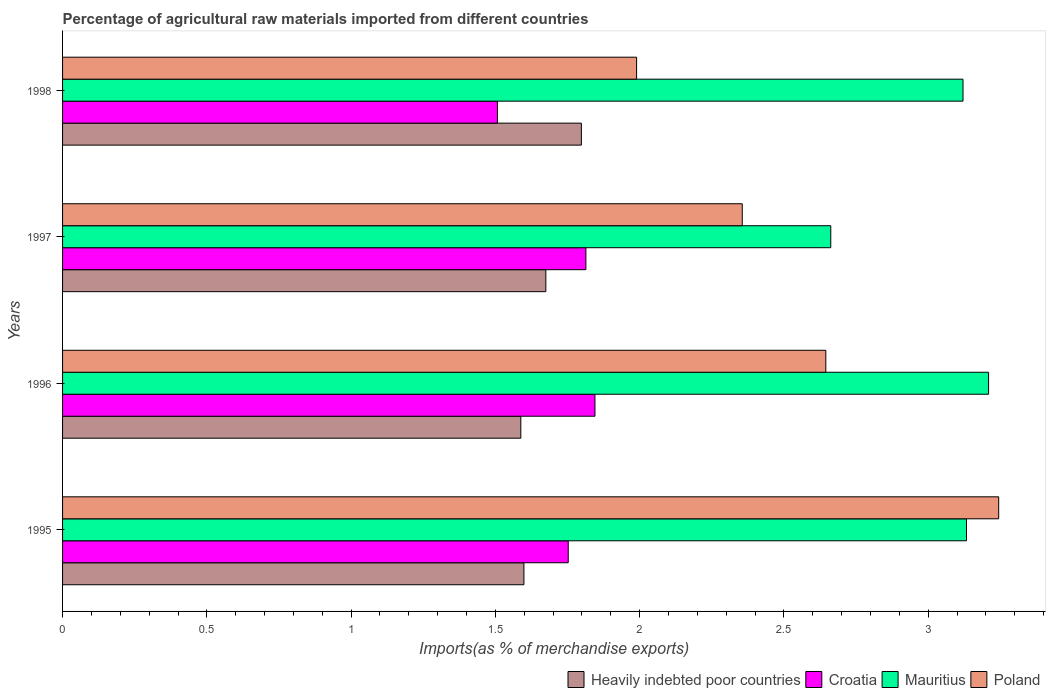How many different coloured bars are there?
Give a very brief answer. 4. Are the number of bars per tick equal to the number of legend labels?
Keep it short and to the point. Yes. Are the number of bars on each tick of the Y-axis equal?
Your answer should be compact. Yes. How many bars are there on the 1st tick from the bottom?
Offer a very short reply. 4. What is the percentage of imports to different countries in Mauritius in 1996?
Your answer should be very brief. 3.21. Across all years, what is the maximum percentage of imports to different countries in Mauritius?
Keep it short and to the point. 3.21. Across all years, what is the minimum percentage of imports to different countries in Mauritius?
Ensure brevity in your answer.  2.66. In which year was the percentage of imports to different countries in Poland minimum?
Your answer should be very brief. 1998. What is the total percentage of imports to different countries in Croatia in the graph?
Offer a terse response. 6.92. What is the difference between the percentage of imports to different countries in Poland in 1996 and that in 1997?
Ensure brevity in your answer.  0.29. What is the difference between the percentage of imports to different countries in Poland in 1998 and the percentage of imports to different countries in Mauritius in 1997?
Give a very brief answer. -0.67. What is the average percentage of imports to different countries in Mauritius per year?
Provide a succinct answer. 3.03. In the year 1997, what is the difference between the percentage of imports to different countries in Croatia and percentage of imports to different countries in Heavily indebted poor countries?
Keep it short and to the point. 0.14. In how many years, is the percentage of imports to different countries in Mauritius greater than 0.30000000000000004 %?
Provide a short and direct response. 4. What is the ratio of the percentage of imports to different countries in Poland in 1995 to that in 1997?
Offer a very short reply. 1.38. Is the percentage of imports to different countries in Croatia in 1997 less than that in 1998?
Offer a very short reply. No. What is the difference between the highest and the second highest percentage of imports to different countries in Heavily indebted poor countries?
Provide a short and direct response. 0.12. What is the difference between the highest and the lowest percentage of imports to different countries in Croatia?
Ensure brevity in your answer.  0.34. What does the 4th bar from the top in 1997 represents?
Your response must be concise. Heavily indebted poor countries. What does the 3rd bar from the bottom in 1998 represents?
Provide a succinct answer. Mauritius. How many bars are there?
Your answer should be compact. 16. Are all the bars in the graph horizontal?
Keep it short and to the point. Yes. How many years are there in the graph?
Your answer should be very brief. 4. Does the graph contain any zero values?
Make the answer very short. No. How are the legend labels stacked?
Your answer should be very brief. Horizontal. What is the title of the graph?
Make the answer very short. Percentage of agricultural raw materials imported from different countries. What is the label or title of the X-axis?
Offer a terse response. Imports(as % of merchandise exports). What is the label or title of the Y-axis?
Offer a terse response. Years. What is the Imports(as % of merchandise exports) of Heavily indebted poor countries in 1995?
Provide a short and direct response. 1.6. What is the Imports(as % of merchandise exports) in Croatia in 1995?
Offer a terse response. 1.75. What is the Imports(as % of merchandise exports) in Mauritius in 1995?
Ensure brevity in your answer.  3.13. What is the Imports(as % of merchandise exports) in Poland in 1995?
Your answer should be very brief. 3.24. What is the Imports(as % of merchandise exports) of Heavily indebted poor countries in 1996?
Make the answer very short. 1.59. What is the Imports(as % of merchandise exports) of Croatia in 1996?
Your response must be concise. 1.84. What is the Imports(as % of merchandise exports) in Mauritius in 1996?
Keep it short and to the point. 3.21. What is the Imports(as % of merchandise exports) of Poland in 1996?
Ensure brevity in your answer.  2.64. What is the Imports(as % of merchandise exports) of Heavily indebted poor countries in 1997?
Provide a succinct answer. 1.67. What is the Imports(as % of merchandise exports) in Croatia in 1997?
Your answer should be very brief. 1.81. What is the Imports(as % of merchandise exports) of Mauritius in 1997?
Give a very brief answer. 2.66. What is the Imports(as % of merchandise exports) of Poland in 1997?
Give a very brief answer. 2.36. What is the Imports(as % of merchandise exports) in Heavily indebted poor countries in 1998?
Your answer should be compact. 1.8. What is the Imports(as % of merchandise exports) in Croatia in 1998?
Provide a succinct answer. 1.51. What is the Imports(as % of merchandise exports) in Mauritius in 1998?
Offer a terse response. 3.12. What is the Imports(as % of merchandise exports) in Poland in 1998?
Offer a terse response. 1.99. Across all years, what is the maximum Imports(as % of merchandise exports) in Heavily indebted poor countries?
Keep it short and to the point. 1.8. Across all years, what is the maximum Imports(as % of merchandise exports) of Croatia?
Ensure brevity in your answer.  1.84. Across all years, what is the maximum Imports(as % of merchandise exports) of Mauritius?
Your response must be concise. 3.21. Across all years, what is the maximum Imports(as % of merchandise exports) in Poland?
Your answer should be compact. 3.24. Across all years, what is the minimum Imports(as % of merchandise exports) in Heavily indebted poor countries?
Keep it short and to the point. 1.59. Across all years, what is the minimum Imports(as % of merchandise exports) of Croatia?
Your answer should be very brief. 1.51. Across all years, what is the minimum Imports(as % of merchandise exports) in Mauritius?
Offer a terse response. 2.66. Across all years, what is the minimum Imports(as % of merchandise exports) in Poland?
Provide a short and direct response. 1.99. What is the total Imports(as % of merchandise exports) in Heavily indebted poor countries in the graph?
Your answer should be compact. 6.66. What is the total Imports(as % of merchandise exports) of Croatia in the graph?
Offer a terse response. 6.92. What is the total Imports(as % of merchandise exports) in Mauritius in the graph?
Your answer should be compact. 12.12. What is the total Imports(as % of merchandise exports) in Poland in the graph?
Provide a succinct answer. 10.23. What is the difference between the Imports(as % of merchandise exports) in Heavily indebted poor countries in 1995 and that in 1996?
Provide a short and direct response. 0.01. What is the difference between the Imports(as % of merchandise exports) in Croatia in 1995 and that in 1996?
Offer a terse response. -0.09. What is the difference between the Imports(as % of merchandise exports) of Mauritius in 1995 and that in 1996?
Provide a short and direct response. -0.08. What is the difference between the Imports(as % of merchandise exports) of Poland in 1995 and that in 1996?
Your response must be concise. 0.6. What is the difference between the Imports(as % of merchandise exports) in Heavily indebted poor countries in 1995 and that in 1997?
Your response must be concise. -0.08. What is the difference between the Imports(as % of merchandise exports) of Croatia in 1995 and that in 1997?
Your response must be concise. -0.06. What is the difference between the Imports(as % of merchandise exports) in Mauritius in 1995 and that in 1997?
Your answer should be compact. 0.47. What is the difference between the Imports(as % of merchandise exports) of Poland in 1995 and that in 1997?
Your response must be concise. 0.89. What is the difference between the Imports(as % of merchandise exports) of Heavily indebted poor countries in 1995 and that in 1998?
Your answer should be very brief. -0.2. What is the difference between the Imports(as % of merchandise exports) of Croatia in 1995 and that in 1998?
Your answer should be compact. 0.25. What is the difference between the Imports(as % of merchandise exports) in Mauritius in 1995 and that in 1998?
Give a very brief answer. 0.01. What is the difference between the Imports(as % of merchandise exports) in Poland in 1995 and that in 1998?
Provide a short and direct response. 1.25. What is the difference between the Imports(as % of merchandise exports) of Heavily indebted poor countries in 1996 and that in 1997?
Keep it short and to the point. -0.09. What is the difference between the Imports(as % of merchandise exports) of Croatia in 1996 and that in 1997?
Make the answer very short. 0.03. What is the difference between the Imports(as % of merchandise exports) of Mauritius in 1996 and that in 1997?
Ensure brevity in your answer.  0.55. What is the difference between the Imports(as % of merchandise exports) in Poland in 1996 and that in 1997?
Your response must be concise. 0.29. What is the difference between the Imports(as % of merchandise exports) in Heavily indebted poor countries in 1996 and that in 1998?
Make the answer very short. -0.21. What is the difference between the Imports(as % of merchandise exports) of Croatia in 1996 and that in 1998?
Your response must be concise. 0.34. What is the difference between the Imports(as % of merchandise exports) in Mauritius in 1996 and that in 1998?
Give a very brief answer. 0.09. What is the difference between the Imports(as % of merchandise exports) in Poland in 1996 and that in 1998?
Offer a terse response. 0.66. What is the difference between the Imports(as % of merchandise exports) of Heavily indebted poor countries in 1997 and that in 1998?
Provide a succinct answer. -0.12. What is the difference between the Imports(as % of merchandise exports) in Croatia in 1997 and that in 1998?
Ensure brevity in your answer.  0.31. What is the difference between the Imports(as % of merchandise exports) of Mauritius in 1997 and that in 1998?
Provide a succinct answer. -0.46. What is the difference between the Imports(as % of merchandise exports) of Poland in 1997 and that in 1998?
Keep it short and to the point. 0.37. What is the difference between the Imports(as % of merchandise exports) of Heavily indebted poor countries in 1995 and the Imports(as % of merchandise exports) of Croatia in 1996?
Give a very brief answer. -0.25. What is the difference between the Imports(as % of merchandise exports) in Heavily indebted poor countries in 1995 and the Imports(as % of merchandise exports) in Mauritius in 1996?
Provide a succinct answer. -1.61. What is the difference between the Imports(as % of merchandise exports) of Heavily indebted poor countries in 1995 and the Imports(as % of merchandise exports) of Poland in 1996?
Give a very brief answer. -1.05. What is the difference between the Imports(as % of merchandise exports) of Croatia in 1995 and the Imports(as % of merchandise exports) of Mauritius in 1996?
Offer a terse response. -1.46. What is the difference between the Imports(as % of merchandise exports) of Croatia in 1995 and the Imports(as % of merchandise exports) of Poland in 1996?
Offer a terse response. -0.89. What is the difference between the Imports(as % of merchandise exports) in Mauritius in 1995 and the Imports(as % of merchandise exports) in Poland in 1996?
Your answer should be very brief. 0.49. What is the difference between the Imports(as % of merchandise exports) in Heavily indebted poor countries in 1995 and the Imports(as % of merchandise exports) in Croatia in 1997?
Keep it short and to the point. -0.21. What is the difference between the Imports(as % of merchandise exports) in Heavily indebted poor countries in 1995 and the Imports(as % of merchandise exports) in Mauritius in 1997?
Make the answer very short. -1.06. What is the difference between the Imports(as % of merchandise exports) of Heavily indebted poor countries in 1995 and the Imports(as % of merchandise exports) of Poland in 1997?
Offer a terse response. -0.76. What is the difference between the Imports(as % of merchandise exports) in Croatia in 1995 and the Imports(as % of merchandise exports) in Mauritius in 1997?
Your answer should be very brief. -0.91. What is the difference between the Imports(as % of merchandise exports) in Croatia in 1995 and the Imports(as % of merchandise exports) in Poland in 1997?
Ensure brevity in your answer.  -0.6. What is the difference between the Imports(as % of merchandise exports) of Mauritius in 1995 and the Imports(as % of merchandise exports) of Poland in 1997?
Offer a very short reply. 0.78. What is the difference between the Imports(as % of merchandise exports) of Heavily indebted poor countries in 1995 and the Imports(as % of merchandise exports) of Croatia in 1998?
Your answer should be compact. 0.09. What is the difference between the Imports(as % of merchandise exports) in Heavily indebted poor countries in 1995 and the Imports(as % of merchandise exports) in Mauritius in 1998?
Keep it short and to the point. -1.52. What is the difference between the Imports(as % of merchandise exports) of Heavily indebted poor countries in 1995 and the Imports(as % of merchandise exports) of Poland in 1998?
Your answer should be very brief. -0.39. What is the difference between the Imports(as % of merchandise exports) in Croatia in 1995 and the Imports(as % of merchandise exports) in Mauritius in 1998?
Ensure brevity in your answer.  -1.37. What is the difference between the Imports(as % of merchandise exports) of Croatia in 1995 and the Imports(as % of merchandise exports) of Poland in 1998?
Keep it short and to the point. -0.24. What is the difference between the Imports(as % of merchandise exports) in Mauritius in 1995 and the Imports(as % of merchandise exports) in Poland in 1998?
Provide a succinct answer. 1.14. What is the difference between the Imports(as % of merchandise exports) in Heavily indebted poor countries in 1996 and the Imports(as % of merchandise exports) in Croatia in 1997?
Keep it short and to the point. -0.23. What is the difference between the Imports(as % of merchandise exports) of Heavily indebted poor countries in 1996 and the Imports(as % of merchandise exports) of Mauritius in 1997?
Provide a short and direct response. -1.07. What is the difference between the Imports(as % of merchandise exports) in Heavily indebted poor countries in 1996 and the Imports(as % of merchandise exports) in Poland in 1997?
Provide a short and direct response. -0.77. What is the difference between the Imports(as % of merchandise exports) in Croatia in 1996 and the Imports(as % of merchandise exports) in Mauritius in 1997?
Provide a succinct answer. -0.82. What is the difference between the Imports(as % of merchandise exports) of Croatia in 1996 and the Imports(as % of merchandise exports) of Poland in 1997?
Provide a short and direct response. -0.51. What is the difference between the Imports(as % of merchandise exports) in Mauritius in 1996 and the Imports(as % of merchandise exports) in Poland in 1997?
Provide a succinct answer. 0.85. What is the difference between the Imports(as % of merchandise exports) in Heavily indebted poor countries in 1996 and the Imports(as % of merchandise exports) in Croatia in 1998?
Your response must be concise. 0.08. What is the difference between the Imports(as % of merchandise exports) of Heavily indebted poor countries in 1996 and the Imports(as % of merchandise exports) of Mauritius in 1998?
Your answer should be very brief. -1.53. What is the difference between the Imports(as % of merchandise exports) of Heavily indebted poor countries in 1996 and the Imports(as % of merchandise exports) of Poland in 1998?
Provide a succinct answer. -0.4. What is the difference between the Imports(as % of merchandise exports) in Croatia in 1996 and the Imports(as % of merchandise exports) in Mauritius in 1998?
Your answer should be very brief. -1.28. What is the difference between the Imports(as % of merchandise exports) of Croatia in 1996 and the Imports(as % of merchandise exports) of Poland in 1998?
Offer a terse response. -0.14. What is the difference between the Imports(as % of merchandise exports) in Mauritius in 1996 and the Imports(as % of merchandise exports) in Poland in 1998?
Ensure brevity in your answer.  1.22. What is the difference between the Imports(as % of merchandise exports) of Heavily indebted poor countries in 1997 and the Imports(as % of merchandise exports) of Croatia in 1998?
Your answer should be compact. 0.17. What is the difference between the Imports(as % of merchandise exports) of Heavily indebted poor countries in 1997 and the Imports(as % of merchandise exports) of Mauritius in 1998?
Provide a succinct answer. -1.45. What is the difference between the Imports(as % of merchandise exports) of Heavily indebted poor countries in 1997 and the Imports(as % of merchandise exports) of Poland in 1998?
Provide a succinct answer. -0.31. What is the difference between the Imports(as % of merchandise exports) of Croatia in 1997 and the Imports(as % of merchandise exports) of Mauritius in 1998?
Keep it short and to the point. -1.31. What is the difference between the Imports(as % of merchandise exports) in Croatia in 1997 and the Imports(as % of merchandise exports) in Poland in 1998?
Give a very brief answer. -0.18. What is the difference between the Imports(as % of merchandise exports) in Mauritius in 1997 and the Imports(as % of merchandise exports) in Poland in 1998?
Provide a short and direct response. 0.67. What is the average Imports(as % of merchandise exports) in Heavily indebted poor countries per year?
Your response must be concise. 1.66. What is the average Imports(as % of merchandise exports) of Croatia per year?
Make the answer very short. 1.73. What is the average Imports(as % of merchandise exports) of Mauritius per year?
Ensure brevity in your answer.  3.03. What is the average Imports(as % of merchandise exports) in Poland per year?
Offer a terse response. 2.56. In the year 1995, what is the difference between the Imports(as % of merchandise exports) of Heavily indebted poor countries and Imports(as % of merchandise exports) of Croatia?
Your answer should be compact. -0.15. In the year 1995, what is the difference between the Imports(as % of merchandise exports) in Heavily indebted poor countries and Imports(as % of merchandise exports) in Mauritius?
Ensure brevity in your answer.  -1.53. In the year 1995, what is the difference between the Imports(as % of merchandise exports) of Heavily indebted poor countries and Imports(as % of merchandise exports) of Poland?
Your answer should be very brief. -1.65. In the year 1995, what is the difference between the Imports(as % of merchandise exports) of Croatia and Imports(as % of merchandise exports) of Mauritius?
Keep it short and to the point. -1.38. In the year 1995, what is the difference between the Imports(as % of merchandise exports) of Croatia and Imports(as % of merchandise exports) of Poland?
Give a very brief answer. -1.49. In the year 1995, what is the difference between the Imports(as % of merchandise exports) in Mauritius and Imports(as % of merchandise exports) in Poland?
Offer a very short reply. -0.11. In the year 1996, what is the difference between the Imports(as % of merchandise exports) in Heavily indebted poor countries and Imports(as % of merchandise exports) in Croatia?
Provide a succinct answer. -0.26. In the year 1996, what is the difference between the Imports(as % of merchandise exports) in Heavily indebted poor countries and Imports(as % of merchandise exports) in Mauritius?
Provide a short and direct response. -1.62. In the year 1996, what is the difference between the Imports(as % of merchandise exports) in Heavily indebted poor countries and Imports(as % of merchandise exports) in Poland?
Give a very brief answer. -1.06. In the year 1996, what is the difference between the Imports(as % of merchandise exports) in Croatia and Imports(as % of merchandise exports) in Mauritius?
Your answer should be very brief. -1.36. In the year 1996, what is the difference between the Imports(as % of merchandise exports) of Croatia and Imports(as % of merchandise exports) of Poland?
Provide a succinct answer. -0.8. In the year 1996, what is the difference between the Imports(as % of merchandise exports) of Mauritius and Imports(as % of merchandise exports) of Poland?
Your answer should be very brief. 0.56. In the year 1997, what is the difference between the Imports(as % of merchandise exports) of Heavily indebted poor countries and Imports(as % of merchandise exports) of Croatia?
Your response must be concise. -0.14. In the year 1997, what is the difference between the Imports(as % of merchandise exports) in Heavily indebted poor countries and Imports(as % of merchandise exports) in Mauritius?
Provide a short and direct response. -0.99. In the year 1997, what is the difference between the Imports(as % of merchandise exports) in Heavily indebted poor countries and Imports(as % of merchandise exports) in Poland?
Your answer should be compact. -0.68. In the year 1997, what is the difference between the Imports(as % of merchandise exports) of Croatia and Imports(as % of merchandise exports) of Mauritius?
Provide a short and direct response. -0.85. In the year 1997, what is the difference between the Imports(as % of merchandise exports) of Croatia and Imports(as % of merchandise exports) of Poland?
Ensure brevity in your answer.  -0.54. In the year 1997, what is the difference between the Imports(as % of merchandise exports) of Mauritius and Imports(as % of merchandise exports) of Poland?
Offer a very short reply. 0.31. In the year 1998, what is the difference between the Imports(as % of merchandise exports) in Heavily indebted poor countries and Imports(as % of merchandise exports) in Croatia?
Offer a very short reply. 0.29. In the year 1998, what is the difference between the Imports(as % of merchandise exports) of Heavily indebted poor countries and Imports(as % of merchandise exports) of Mauritius?
Your response must be concise. -1.32. In the year 1998, what is the difference between the Imports(as % of merchandise exports) of Heavily indebted poor countries and Imports(as % of merchandise exports) of Poland?
Provide a succinct answer. -0.19. In the year 1998, what is the difference between the Imports(as % of merchandise exports) in Croatia and Imports(as % of merchandise exports) in Mauritius?
Offer a terse response. -1.61. In the year 1998, what is the difference between the Imports(as % of merchandise exports) in Croatia and Imports(as % of merchandise exports) in Poland?
Make the answer very short. -0.48. In the year 1998, what is the difference between the Imports(as % of merchandise exports) of Mauritius and Imports(as % of merchandise exports) of Poland?
Make the answer very short. 1.13. What is the ratio of the Imports(as % of merchandise exports) of Heavily indebted poor countries in 1995 to that in 1996?
Your answer should be very brief. 1.01. What is the ratio of the Imports(as % of merchandise exports) in Croatia in 1995 to that in 1996?
Your response must be concise. 0.95. What is the ratio of the Imports(as % of merchandise exports) in Mauritius in 1995 to that in 1996?
Keep it short and to the point. 0.98. What is the ratio of the Imports(as % of merchandise exports) of Poland in 1995 to that in 1996?
Offer a terse response. 1.23. What is the ratio of the Imports(as % of merchandise exports) of Heavily indebted poor countries in 1995 to that in 1997?
Offer a very short reply. 0.95. What is the ratio of the Imports(as % of merchandise exports) of Croatia in 1995 to that in 1997?
Ensure brevity in your answer.  0.97. What is the ratio of the Imports(as % of merchandise exports) of Mauritius in 1995 to that in 1997?
Keep it short and to the point. 1.18. What is the ratio of the Imports(as % of merchandise exports) of Poland in 1995 to that in 1997?
Ensure brevity in your answer.  1.38. What is the ratio of the Imports(as % of merchandise exports) of Heavily indebted poor countries in 1995 to that in 1998?
Offer a very short reply. 0.89. What is the ratio of the Imports(as % of merchandise exports) of Croatia in 1995 to that in 1998?
Give a very brief answer. 1.16. What is the ratio of the Imports(as % of merchandise exports) of Mauritius in 1995 to that in 1998?
Your answer should be very brief. 1. What is the ratio of the Imports(as % of merchandise exports) in Poland in 1995 to that in 1998?
Ensure brevity in your answer.  1.63. What is the ratio of the Imports(as % of merchandise exports) of Heavily indebted poor countries in 1996 to that in 1997?
Offer a very short reply. 0.95. What is the ratio of the Imports(as % of merchandise exports) of Croatia in 1996 to that in 1997?
Ensure brevity in your answer.  1.02. What is the ratio of the Imports(as % of merchandise exports) of Mauritius in 1996 to that in 1997?
Offer a terse response. 1.21. What is the ratio of the Imports(as % of merchandise exports) of Poland in 1996 to that in 1997?
Keep it short and to the point. 1.12. What is the ratio of the Imports(as % of merchandise exports) in Heavily indebted poor countries in 1996 to that in 1998?
Your response must be concise. 0.88. What is the ratio of the Imports(as % of merchandise exports) of Croatia in 1996 to that in 1998?
Your answer should be compact. 1.22. What is the ratio of the Imports(as % of merchandise exports) in Mauritius in 1996 to that in 1998?
Your answer should be compact. 1.03. What is the ratio of the Imports(as % of merchandise exports) in Poland in 1996 to that in 1998?
Provide a short and direct response. 1.33. What is the ratio of the Imports(as % of merchandise exports) in Heavily indebted poor countries in 1997 to that in 1998?
Offer a terse response. 0.93. What is the ratio of the Imports(as % of merchandise exports) in Croatia in 1997 to that in 1998?
Offer a terse response. 1.2. What is the ratio of the Imports(as % of merchandise exports) of Mauritius in 1997 to that in 1998?
Offer a terse response. 0.85. What is the ratio of the Imports(as % of merchandise exports) of Poland in 1997 to that in 1998?
Offer a terse response. 1.18. What is the difference between the highest and the second highest Imports(as % of merchandise exports) in Heavily indebted poor countries?
Your answer should be very brief. 0.12. What is the difference between the highest and the second highest Imports(as % of merchandise exports) of Croatia?
Your answer should be compact. 0.03. What is the difference between the highest and the second highest Imports(as % of merchandise exports) in Mauritius?
Provide a short and direct response. 0.08. What is the difference between the highest and the second highest Imports(as % of merchandise exports) in Poland?
Your response must be concise. 0.6. What is the difference between the highest and the lowest Imports(as % of merchandise exports) of Heavily indebted poor countries?
Your response must be concise. 0.21. What is the difference between the highest and the lowest Imports(as % of merchandise exports) in Croatia?
Make the answer very short. 0.34. What is the difference between the highest and the lowest Imports(as % of merchandise exports) of Mauritius?
Make the answer very short. 0.55. What is the difference between the highest and the lowest Imports(as % of merchandise exports) of Poland?
Offer a very short reply. 1.25. 